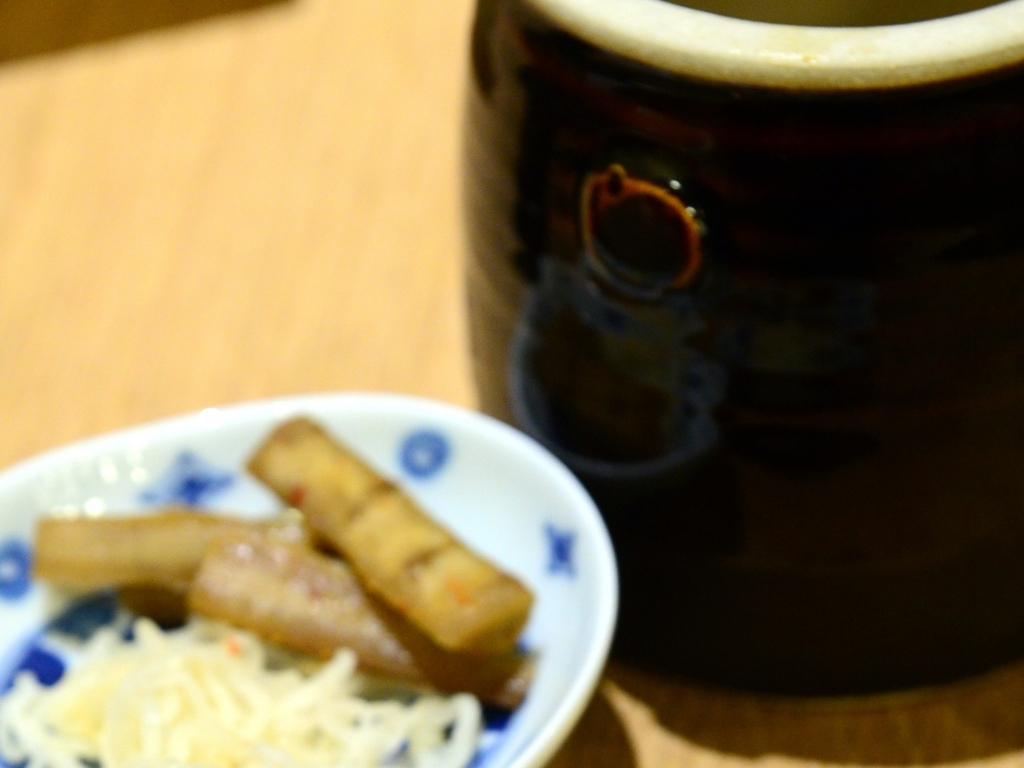What issue does this image have?
A. The image has excellent sharpness and focusing.
B. The image has average sharpness and focusing.
C. The image has a general lack of sharpness and focusing issue.
Answer with the option's letter from the given choices directly.
 C. 